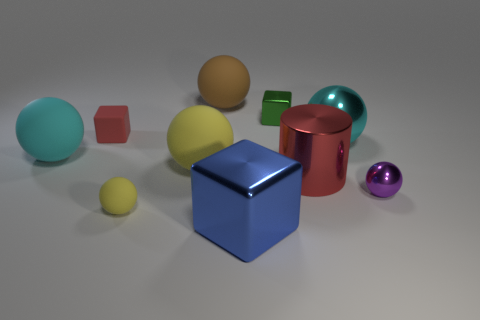Is the size of the red shiny cylinder the same as the metal cube in front of the cyan matte object?
Your response must be concise. Yes. The small ball that is to the right of the metallic cylinder that is to the left of the cyan metal sphere is made of what material?
Offer a very short reply. Metal. Is the number of cyan balls on the right side of the large metal sphere the same as the number of green metal cylinders?
Give a very brief answer. Yes. There is a thing that is both in front of the red metallic object and left of the big yellow matte sphere; how big is it?
Provide a succinct answer. Small. What is the color of the tiny metallic object on the left side of the tiny purple object that is in front of the red metal cylinder?
Provide a succinct answer. Green. How many cyan objects are tiny shiny blocks or rubber spheres?
Keep it short and to the point. 1. What color is the thing that is left of the tiny green thing and behind the red block?
Your response must be concise. Brown. What number of tiny objects are either blue metal objects or cyan matte things?
Provide a succinct answer. 0. The green thing that is the same shape as the small red thing is what size?
Keep it short and to the point. Small. What is the shape of the small yellow matte thing?
Make the answer very short. Sphere. 